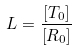Convert formula to latex. <formula><loc_0><loc_0><loc_500><loc_500>L = \frac { [ T _ { 0 } ] } { [ R _ { 0 } ] }</formula> 